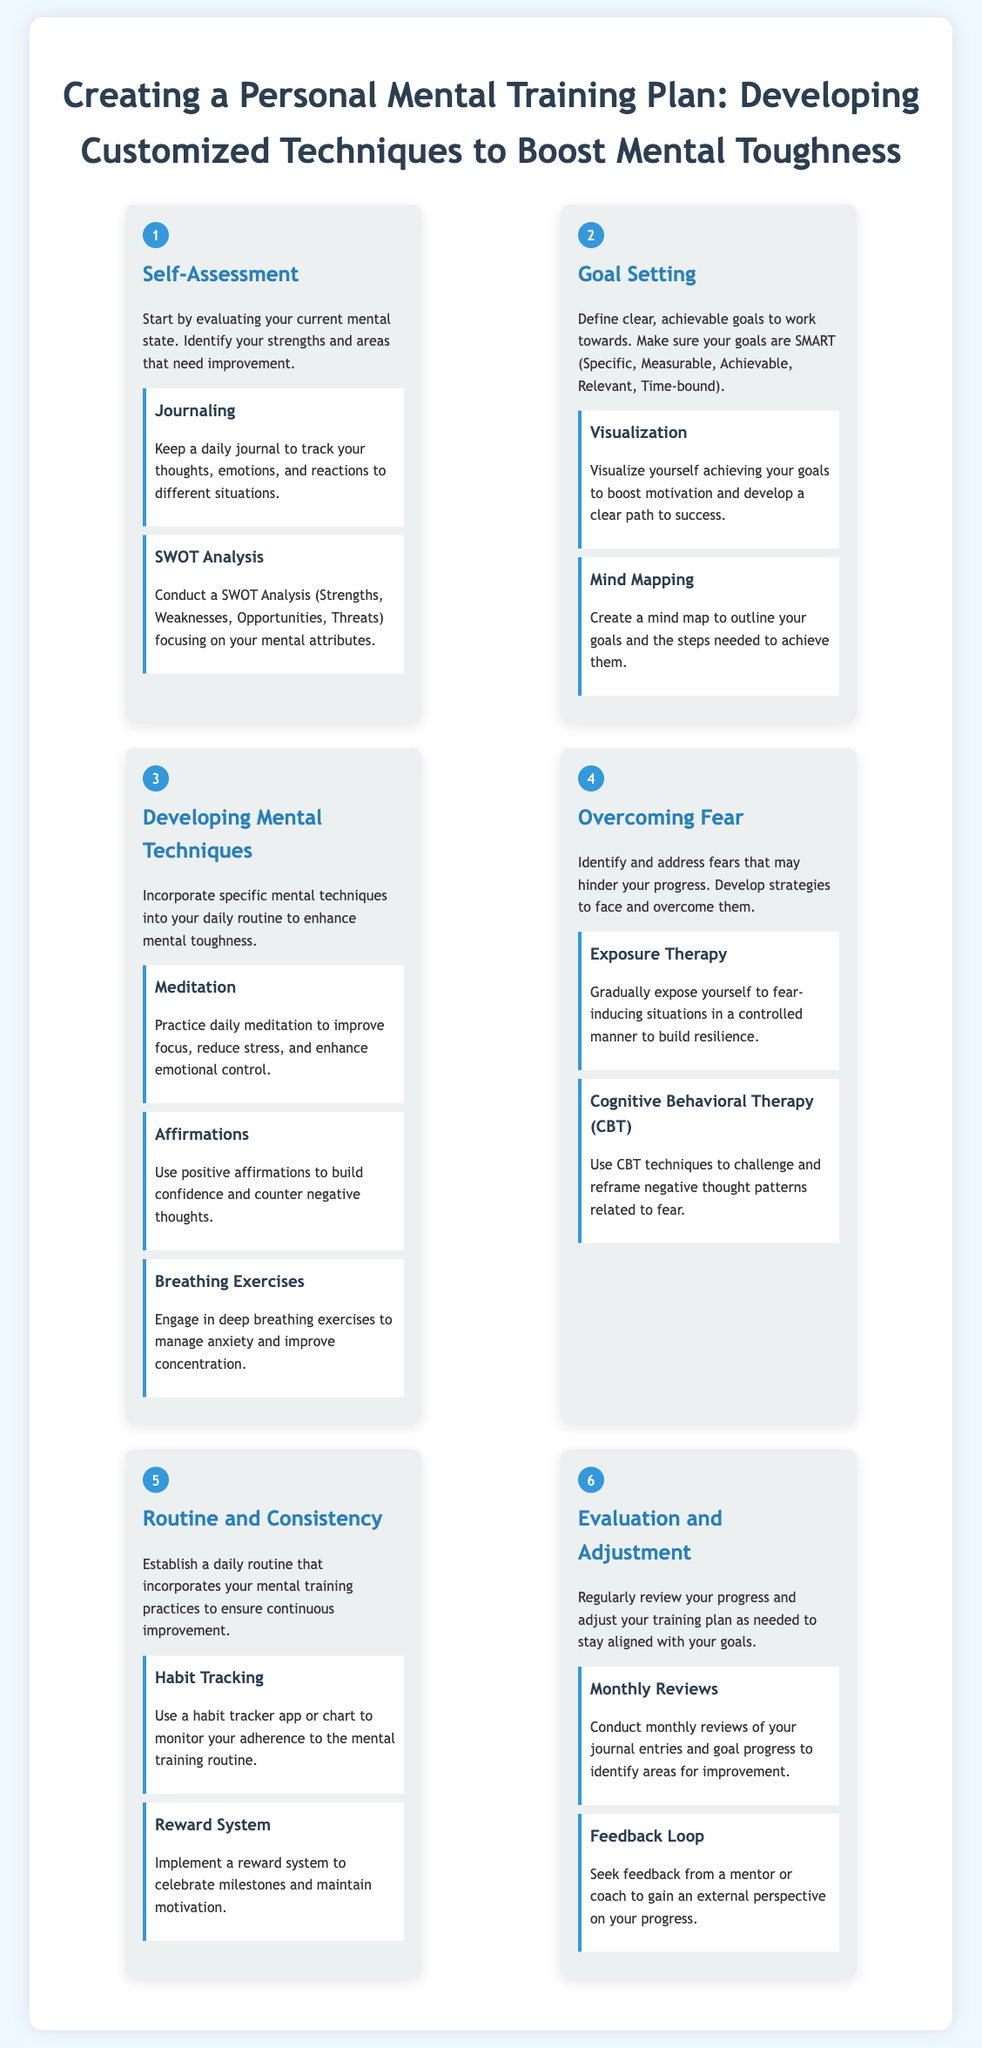What is the first step in creating a personal mental training plan? The first step outlined in the document is "Self-Assessment."
Answer: Self-Assessment How many mental techniques are suggested for developing mental toughness? The document lists three techniques under "Developing Mental Techniques."
Answer: Three What does SMART stand for in goal setting? The document mentions that goals should be Specific, Measurable, Achievable, Relevant, Time-bound, but does not explicitly define it.
Answer: Specific, Measurable, Achievable, Relevant, Time-bound Which technique is recommended for managing anxiety? The document states that "Breathing Exercises" should be used to manage anxiety.
Answer: Breathing Exercises What is a common method of tracking progress mentioned in the document? "Habit Tracking" is mentioned as a method to monitor adherence to the mental training routine.
Answer: Habit Tracking How often should monthly reviews be conducted? The document suggests conducting monthly reviews to assess progress.
Answer: Monthly What should individuals develop strategies for in step four? Individuals should develop strategies to face and overcome fears that may hinder progress.
Answer: Fears What is the final step in the mental training process? The last step outlined is "Evaluation and Adjustment."
Answer: Evaluation and Adjustment 